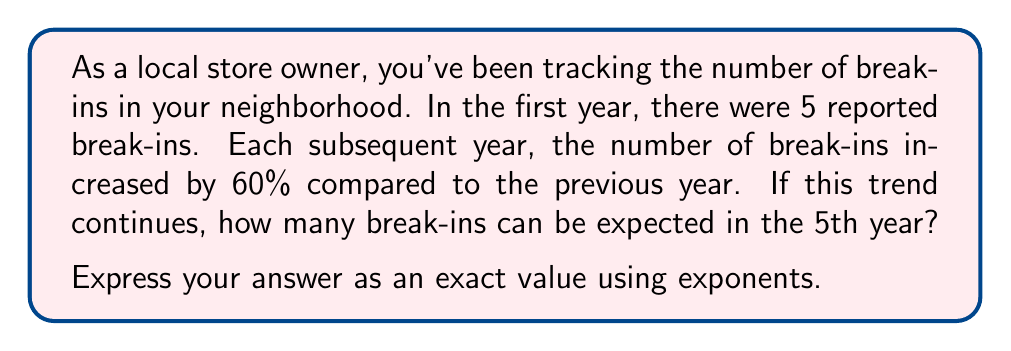Give your solution to this math problem. Let's approach this step-by-step:

1) First, we need to understand what a 60% increase means. It means that each year, the number of break-ins is 160% of the previous year, or 1.6 times the previous year.

2) We can express this as an exponential function:
   $B_n = 5 \times 1.6^{n-1}$
   Where $B_n$ is the number of break-ins in year $n$, and 5 is the initial number of break-ins.

3) We're asked about the 5th year, so we need to calculate $B_5$:

   $B_5 = 5 \times 1.6^{5-1} = 5 \times 1.6^4$

4) Now, let's calculate $1.6^4$:
   $1.6^4 = 1.6 \times 1.6 \times 1.6 \times 1.6 = 6.5536$

5) Finally, we multiply this by our initial value:
   $5 \times 6.5536 = 32.768$

However, since we're asked to express the answer as an exact value using exponents, we'll leave it in the form $5 \times 1.6^4$.
Answer: $5 \times 1.6^4$ break-ins 